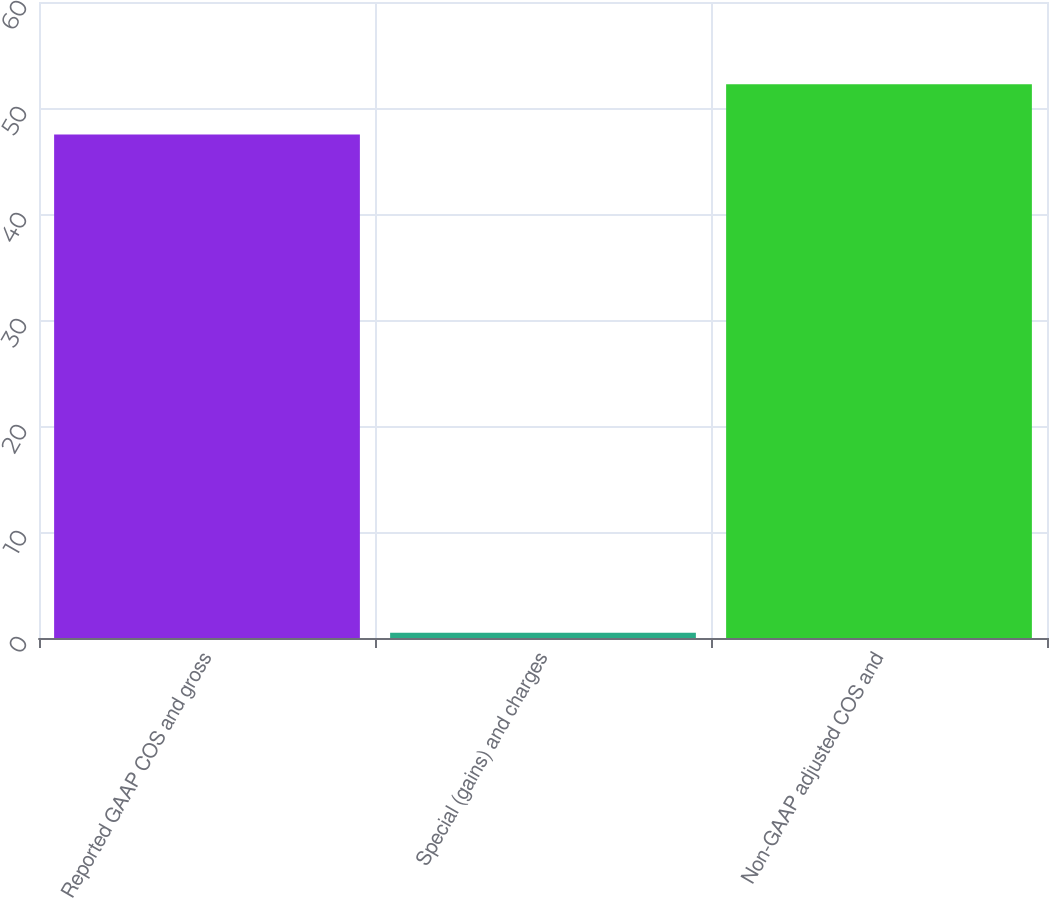Convert chart to OTSL. <chart><loc_0><loc_0><loc_500><loc_500><bar_chart><fcel>Reported GAAP COS and gross<fcel>Special (gains) and charges<fcel>Non-GAAP adjusted COS and<nl><fcel>47.5<fcel>0.5<fcel>52.25<nl></chart> 